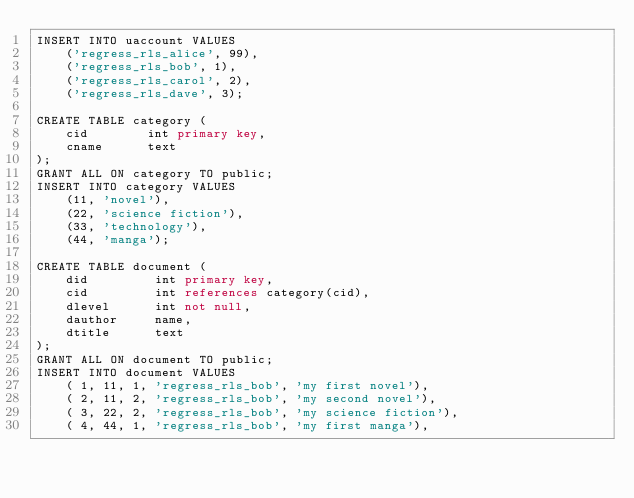Convert code to text. <code><loc_0><loc_0><loc_500><loc_500><_SQL_>INSERT INTO uaccount VALUES
    ('regress_rls_alice', 99),
    ('regress_rls_bob', 1),
    ('regress_rls_carol', 2),
    ('regress_rls_dave', 3);

CREATE TABLE category (
    cid        int primary key,
    cname      text
);
GRANT ALL ON category TO public;
INSERT INTO category VALUES
    (11, 'novel'),
    (22, 'science fiction'),
    (33, 'technology'),
    (44, 'manga');

CREATE TABLE document (
    did         int primary key,
    cid         int references category(cid),
    dlevel      int not null,
    dauthor     name,
    dtitle      text
);
GRANT ALL ON document TO public;
INSERT INTO document VALUES
    ( 1, 11, 1, 'regress_rls_bob', 'my first novel'),
    ( 2, 11, 2, 'regress_rls_bob', 'my second novel'),
    ( 3, 22, 2, 'regress_rls_bob', 'my science fiction'),
    ( 4, 44, 1, 'regress_rls_bob', 'my first manga'),</code> 